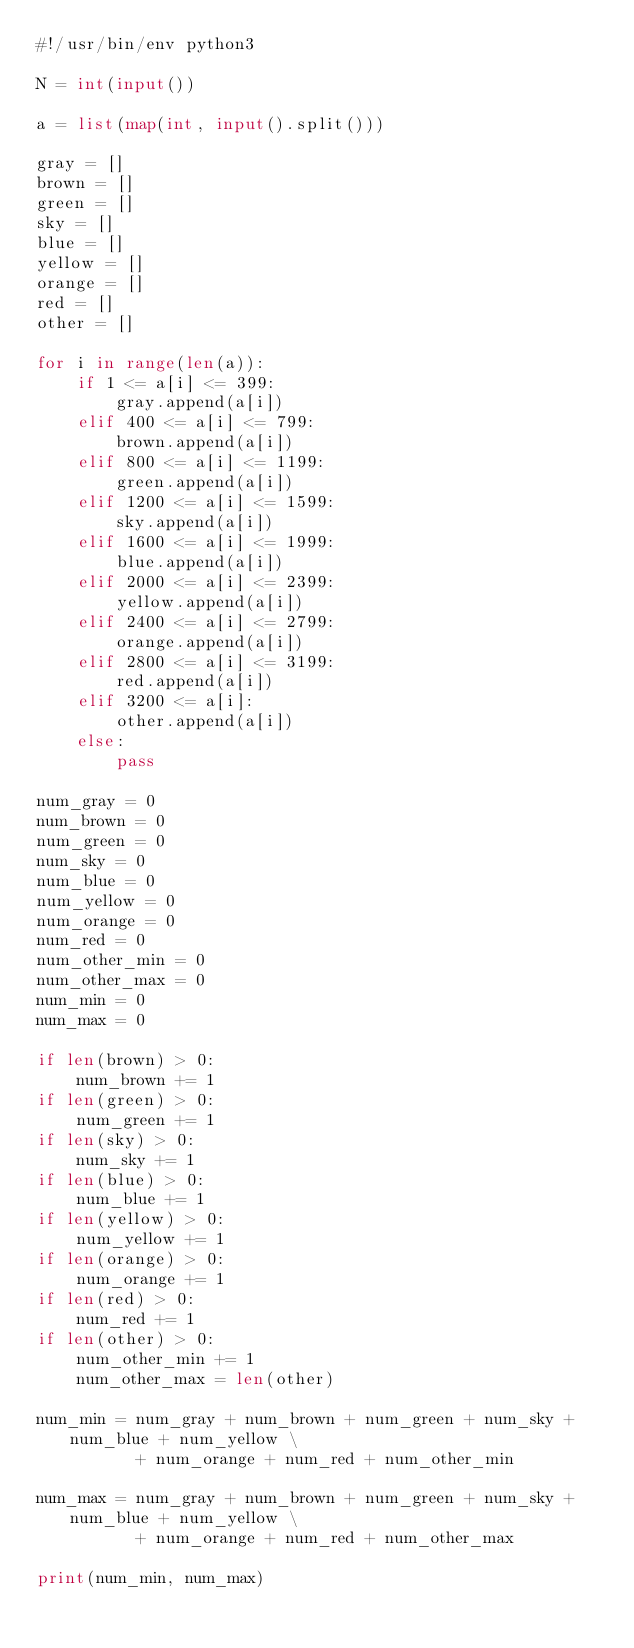<code> <loc_0><loc_0><loc_500><loc_500><_Python_>#!/usr/bin/env python3

N = int(input())

a = list(map(int, input().split()))

gray = []
brown = []
green = []
sky = []
blue = []
yellow = []
orange = []
red = []
other = []

for i in range(len(a)):
    if 1 <= a[i] <= 399:
        gray.append(a[i])
    elif 400 <= a[i] <= 799:
        brown.append(a[i])
    elif 800 <= a[i] <= 1199:
        green.append(a[i])
    elif 1200 <= a[i] <= 1599:
        sky.append(a[i])
    elif 1600 <= a[i] <= 1999:
        blue.append(a[i])
    elif 2000 <= a[i] <= 2399:
        yellow.append(a[i])
    elif 2400 <= a[i] <= 2799:
        orange.append(a[i])
    elif 2800 <= a[i] <= 3199:
        red.append(a[i])
    elif 3200 <= a[i]:
        other.append(a[i])
    else:
        pass

num_gray = 0
num_brown = 0
num_green = 0
num_sky = 0
num_blue = 0
num_yellow = 0
num_orange = 0
num_red = 0
num_other_min = 0
num_other_max = 0
num_min = 0
num_max = 0

if len(brown) > 0:
    num_brown += 1
if len(green) > 0:
    num_green += 1
if len(sky) > 0:
    num_sky += 1
if len(blue) > 0:
    num_blue += 1
if len(yellow) > 0:
    num_yellow += 1
if len(orange) > 0:
    num_orange += 1
if len(red) > 0:
    num_red += 1
if len(other) > 0:
    num_other_min += 1
    num_other_max = len(other)

num_min = num_gray + num_brown + num_green + num_sky + num_blue + num_yellow \
          + num_orange + num_red + num_other_min

num_max = num_gray + num_brown + num_green + num_sky + num_blue + num_yellow \
          + num_orange + num_red + num_other_max

print(num_min, num_max)</code> 